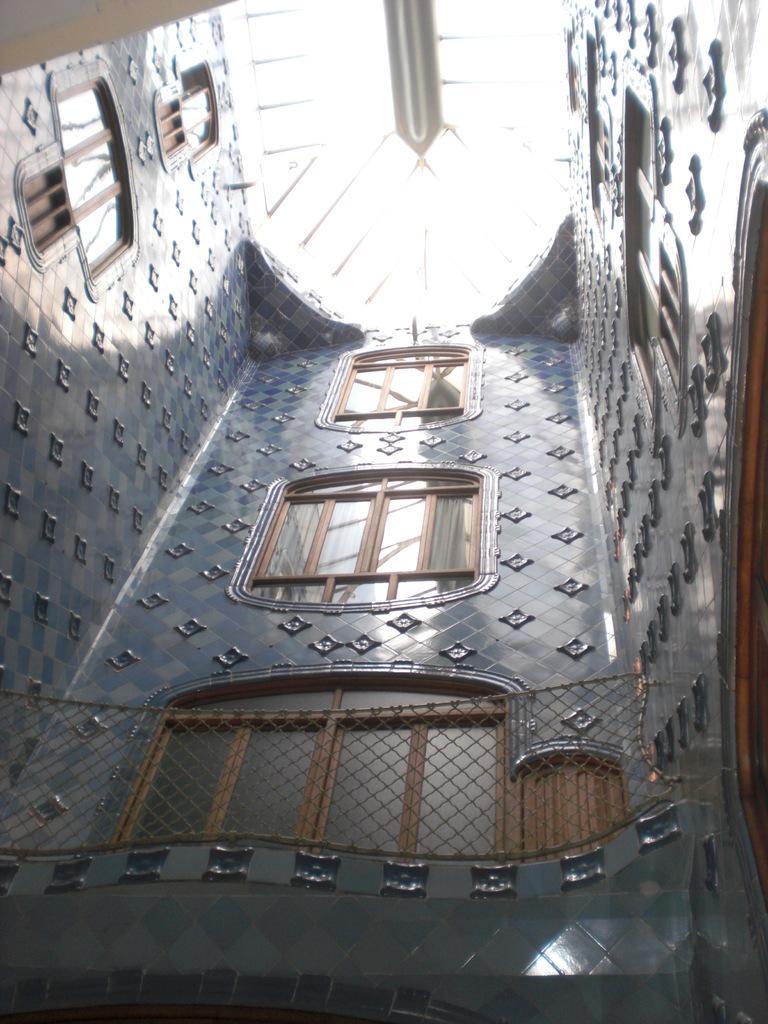Please provide a concise description of this image. In this picture I can see the inside view of a building, there are windows and there is fence. 